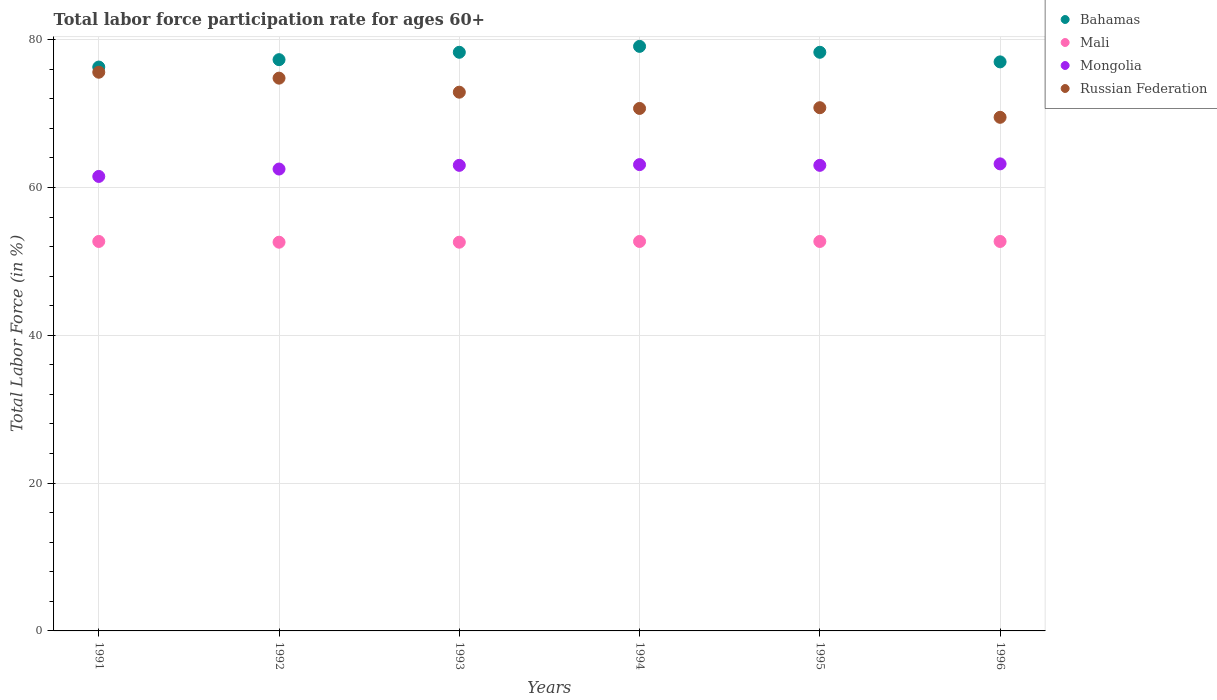How many different coloured dotlines are there?
Your answer should be compact. 4. What is the labor force participation rate in Mali in 1996?
Offer a terse response. 52.7. Across all years, what is the maximum labor force participation rate in Mongolia?
Your answer should be compact. 63.2. Across all years, what is the minimum labor force participation rate in Russian Federation?
Offer a terse response. 69.5. In which year was the labor force participation rate in Bahamas maximum?
Offer a terse response. 1994. What is the total labor force participation rate in Bahamas in the graph?
Provide a short and direct response. 466.3. What is the difference between the labor force participation rate in Mongolia in 1993 and that in 1994?
Keep it short and to the point. -0.1. What is the difference between the labor force participation rate in Russian Federation in 1994 and the labor force participation rate in Mali in 1992?
Offer a very short reply. 18.1. What is the average labor force participation rate in Russian Federation per year?
Your response must be concise. 72.38. In the year 1994, what is the difference between the labor force participation rate in Mongolia and labor force participation rate in Russian Federation?
Give a very brief answer. -7.6. Is the difference between the labor force participation rate in Mongolia in 1993 and 1996 greater than the difference between the labor force participation rate in Russian Federation in 1993 and 1996?
Ensure brevity in your answer.  No. What is the difference between the highest and the second highest labor force participation rate in Russian Federation?
Offer a terse response. 0.8. What is the difference between the highest and the lowest labor force participation rate in Mali?
Your answer should be compact. 0.1. In how many years, is the labor force participation rate in Mongolia greater than the average labor force participation rate in Mongolia taken over all years?
Offer a terse response. 4. Is the sum of the labor force participation rate in Bahamas in 1993 and 1996 greater than the maximum labor force participation rate in Russian Federation across all years?
Provide a succinct answer. Yes. Does the labor force participation rate in Mongolia monotonically increase over the years?
Make the answer very short. No. Is the labor force participation rate in Mongolia strictly greater than the labor force participation rate in Bahamas over the years?
Ensure brevity in your answer.  No. Is the labor force participation rate in Mali strictly less than the labor force participation rate in Russian Federation over the years?
Make the answer very short. Yes. How many years are there in the graph?
Your response must be concise. 6. What is the difference between two consecutive major ticks on the Y-axis?
Your answer should be very brief. 20. Are the values on the major ticks of Y-axis written in scientific E-notation?
Provide a short and direct response. No. Does the graph contain any zero values?
Keep it short and to the point. No. Does the graph contain grids?
Offer a terse response. Yes. Where does the legend appear in the graph?
Ensure brevity in your answer.  Top right. How are the legend labels stacked?
Offer a very short reply. Vertical. What is the title of the graph?
Your response must be concise. Total labor force participation rate for ages 60+. Does "Maldives" appear as one of the legend labels in the graph?
Offer a very short reply. No. What is the label or title of the X-axis?
Your response must be concise. Years. What is the Total Labor Force (in %) in Bahamas in 1991?
Provide a short and direct response. 76.3. What is the Total Labor Force (in %) in Mali in 1991?
Provide a short and direct response. 52.7. What is the Total Labor Force (in %) in Mongolia in 1991?
Provide a succinct answer. 61.5. What is the Total Labor Force (in %) in Russian Federation in 1991?
Keep it short and to the point. 75.6. What is the Total Labor Force (in %) in Bahamas in 1992?
Offer a very short reply. 77.3. What is the Total Labor Force (in %) of Mali in 1992?
Make the answer very short. 52.6. What is the Total Labor Force (in %) in Mongolia in 1992?
Ensure brevity in your answer.  62.5. What is the Total Labor Force (in %) of Russian Federation in 1992?
Your response must be concise. 74.8. What is the Total Labor Force (in %) of Bahamas in 1993?
Keep it short and to the point. 78.3. What is the Total Labor Force (in %) of Mali in 1993?
Ensure brevity in your answer.  52.6. What is the Total Labor Force (in %) of Russian Federation in 1993?
Provide a short and direct response. 72.9. What is the Total Labor Force (in %) of Bahamas in 1994?
Your answer should be compact. 79.1. What is the Total Labor Force (in %) of Mali in 1994?
Keep it short and to the point. 52.7. What is the Total Labor Force (in %) in Mongolia in 1994?
Your response must be concise. 63.1. What is the Total Labor Force (in %) of Russian Federation in 1994?
Your answer should be very brief. 70.7. What is the Total Labor Force (in %) in Bahamas in 1995?
Offer a very short reply. 78.3. What is the Total Labor Force (in %) in Mali in 1995?
Give a very brief answer. 52.7. What is the Total Labor Force (in %) in Mongolia in 1995?
Keep it short and to the point. 63. What is the Total Labor Force (in %) in Russian Federation in 1995?
Your response must be concise. 70.8. What is the Total Labor Force (in %) of Bahamas in 1996?
Your answer should be very brief. 77. What is the Total Labor Force (in %) in Mali in 1996?
Make the answer very short. 52.7. What is the Total Labor Force (in %) in Mongolia in 1996?
Make the answer very short. 63.2. What is the Total Labor Force (in %) in Russian Federation in 1996?
Your answer should be compact. 69.5. Across all years, what is the maximum Total Labor Force (in %) of Bahamas?
Provide a short and direct response. 79.1. Across all years, what is the maximum Total Labor Force (in %) of Mali?
Offer a terse response. 52.7. Across all years, what is the maximum Total Labor Force (in %) in Mongolia?
Give a very brief answer. 63.2. Across all years, what is the maximum Total Labor Force (in %) in Russian Federation?
Make the answer very short. 75.6. Across all years, what is the minimum Total Labor Force (in %) in Bahamas?
Make the answer very short. 76.3. Across all years, what is the minimum Total Labor Force (in %) in Mali?
Your answer should be compact. 52.6. Across all years, what is the minimum Total Labor Force (in %) in Mongolia?
Your answer should be very brief. 61.5. Across all years, what is the minimum Total Labor Force (in %) in Russian Federation?
Ensure brevity in your answer.  69.5. What is the total Total Labor Force (in %) of Bahamas in the graph?
Ensure brevity in your answer.  466.3. What is the total Total Labor Force (in %) of Mali in the graph?
Your answer should be very brief. 316. What is the total Total Labor Force (in %) of Mongolia in the graph?
Your answer should be very brief. 376.3. What is the total Total Labor Force (in %) in Russian Federation in the graph?
Provide a short and direct response. 434.3. What is the difference between the Total Labor Force (in %) of Mali in 1991 and that in 1992?
Your answer should be very brief. 0.1. What is the difference between the Total Labor Force (in %) of Russian Federation in 1991 and that in 1992?
Provide a succinct answer. 0.8. What is the difference between the Total Labor Force (in %) in Bahamas in 1991 and that in 1993?
Your response must be concise. -2. What is the difference between the Total Labor Force (in %) in Mali in 1991 and that in 1993?
Your answer should be compact. 0.1. What is the difference between the Total Labor Force (in %) of Mongolia in 1991 and that in 1993?
Provide a short and direct response. -1.5. What is the difference between the Total Labor Force (in %) of Bahamas in 1991 and that in 1995?
Provide a succinct answer. -2. What is the difference between the Total Labor Force (in %) of Mali in 1991 and that in 1995?
Ensure brevity in your answer.  0. What is the difference between the Total Labor Force (in %) of Mongolia in 1991 and that in 1995?
Your answer should be very brief. -1.5. What is the difference between the Total Labor Force (in %) in Bahamas in 1991 and that in 1996?
Provide a succinct answer. -0.7. What is the difference between the Total Labor Force (in %) in Mali in 1991 and that in 1996?
Ensure brevity in your answer.  0. What is the difference between the Total Labor Force (in %) in Russian Federation in 1991 and that in 1996?
Offer a terse response. 6.1. What is the difference between the Total Labor Force (in %) in Bahamas in 1992 and that in 1993?
Offer a very short reply. -1. What is the difference between the Total Labor Force (in %) in Mali in 1992 and that in 1993?
Offer a very short reply. 0. What is the difference between the Total Labor Force (in %) in Mongolia in 1992 and that in 1993?
Make the answer very short. -0.5. What is the difference between the Total Labor Force (in %) in Russian Federation in 1992 and that in 1993?
Keep it short and to the point. 1.9. What is the difference between the Total Labor Force (in %) in Bahamas in 1992 and that in 1994?
Your answer should be compact. -1.8. What is the difference between the Total Labor Force (in %) of Russian Federation in 1992 and that in 1994?
Provide a short and direct response. 4.1. What is the difference between the Total Labor Force (in %) in Russian Federation in 1992 and that in 1995?
Provide a short and direct response. 4. What is the difference between the Total Labor Force (in %) in Mali in 1992 and that in 1996?
Give a very brief answer. -0.1. What is the difference between the Total Labor Force (in %) in Mongolia in 1992 and that in 1996?
Your answer should be very brief. -0.7. What is the difference between the Total Labor Force (in %) of Bahamas in 1993 and that in 1994?
Give a very brief answer. -0.8. What is the difference between the Total Labor Force (in %) of Mali in 1993 and that in 1994?
Provide a succinct answer. -0.1. What is the difference between the Total Labor Force (in %) in Mongolia in 1993 and that in 1994?
Give a very brief answer. -0.1. What is the difference between the Total Labor Force (in %) in Russian Federation in 1993 and that in 1994?
Your answer should be compact. 2.2. What is the difference between the Total Labor Force (in %) of Bahamas in 1993 and that in 1995?
Offer a very short reply. 0. What is the difference between the Total Labor Force (in %) in Mali in 1993 and that in 1995?
Provide a short and direct response. -0.1. What is the difference between the Total Labor Force (in %) of Mongolia in 1993 and that in 1995?
Provide a succinct answer. 0. What is the difference between the Total Labor Force (in %) in Russian Federation in 1993 and that in 1995?
Give a very brief answer. 2.1. What is the difference between the Total Labor Force (in %) in Bahamas in 1994 and that in 1996?
Ensure brevity in your answer.  2.1. What is the difference between the Total Labor Force (in %) of Mali in 1994 and that in 1996?
Provide a succinct answer. 0. What is the difference between the Total Labor Force (in %) of Mongolia in 1994 and that in 1996?
Provide a succinct answer. -0.1. What is the difference between the Total Labor Force (in %) of Mali in 1995 and that in 1996?
Provide a succinct answer. 0. What is the difference between the Total Labor Force (in %) in Bahamas in 1991 and the Total Labor Force (in %) in Mali in 1992?
Your answer should be very brief. 23.7. What is the difference between the Total Labor Force (in %) of Bahamas in 1991 and the Total Labor Force (in %) of Mongolia in 1992?
Offer a terse response. 13.8. What is the difference between the Total Labor Force (in %) in Mali in 1991 and the Total Labor Force (in %) in Russian Federation in 1992?
Keep it short and to the point. -22.1. What is the difference between the Total Labor Force (in %) in Bahamas in 1991 and the Total Labor Force (in %) in Mali in 1993?
Provide a short and direct response. 23.7. What is the difference between the Total Labor Force (in %) in Bahamas in 1991 and the Total Labor Force (in %) in Mongolia in 1993?
Provide a succinct answer. 13.3. What is the difference between the Total Labor Force (in %) in Mali in 1991 and the Total Labor Force (in %) in Mongolia in 1993?
Your response must be concise. -10.3. What is the difference between the Total Labor Force (in %) in Mali in 1991 and the Total Labor Force (in %) in Russian Federation in 1993?
Keep it short and to the point. -20.2. What is the difference between the Total Labor Force (in %) in Bahamas in 1991 and the Total Labor Force (in %) in Mali in 1994?
Keep it short and to the point. 23.6. What is the difference between the Total Labor Force (in %) in Mali in 1991 and the Total Labor Force (in %) in Mongolia in 1994?
Provide a short and direct response. -10.4. What is the difference between the Total Labor Force (in %) in Mongolia in 1991 and the Total Labor Force (in %) in Russian Federation in 1994?
Keep it short and to the point. -9.2. What is the difference between the Total Labor Force (in %) in Bahamas in 1991 and the Total Labor Force (in %) in Mali in 1995?
Your response must be concise. 23.6. What is the difference between the Total Labor Force (in %) in Bahamas in 1991 and the Total Labor Force (in %) in Mongolia in 1995?
Ensure brevity in your answer.  13.3. What is the difference between the Total Labor Force (in %) in Mali in 1991 and the Total Labor Force (in %) in Mongolia in 1995?
Ensure brevity in your answer.  -10.3. What is the difference between the Total Labor Force (in %) in Mali in 1991 and the Total Labor Force (in %) in Russian Federation in 1995?
Make the answer very short. -18.1. What is the difference between the Total Labor Force (in %) in Mongolia in 1991 and the Total Labor Force (in %) in Russian Federation in 1995?
Give a very brief answer. -9.3. What is the difference between the Total Labor Force (in %) in Bahamas in 1991 and the Total Labor Force (in %) in Mali in 1996?
Ensure brevity in your answer.  23.6. What is the difference between the Total Labor Force (in %) of Bahamas in 1991 and the Total Labor Force (in %) of Mongolia in 1996?
Provide a short and direct response. 13.1. What is the difference between the Total Labor Force (in %) of Mali in 1991 and the Total Labor Force (in %) of Mongolia in 1996?
Your response must be concise. -10.5. What is the difference between the Total Labor Force (in %) in Mali in 1991 and the Total Labor Force (in %) in Russian Federation in 1996?
Your answer should be compact. -16.8. What is the difference between the Total Labor Force (in %) of Mongolia in 1991 and the Total Labor Force (in %) of Russian Federation in 1996?
Keep it short and to the point. -8. What is the difference between the Total Labor Force (in %) in Bahamas in 1992 and the Total Labor Force (in %) in Mali in 1993?
Offer a very short reply. 24.7. What is the difference between the Total Labor Force (in %) of Bahamas in 1992 and the Total Labor Force (in %) of Mongolia in 1993?
Ensure brevity in your answer.  14.3. What is the difference between the Total Labor Force (in %) of Bahamas in 1992 and the Total Labor Force (in %) of Russian Federation in 1993?
Your answer should be very brief. 4.4. What is the difference between the Total Labor Force (in %) of Mali in 1992 and the Total Labor Force (in %) of Mongolia in 1993?
Give a very brief answer. -10.4. What is the difference between the Total Labor Force (in %) in Mali in 1992 and the Total Labor Force (in %) in Russian Federation in 1993?
Offer a very short reply. -20.3. What is the difference between the Total Labor Force (in %) of Mongolia in 1992 and the Total Labor Force (in %) of Russian Federation in 1993?
Make the answer very short. -10.4. What is the difference between the Total Labor Force (in %) of Bahamas in 1992 and the Total Labor Force (in %) of Mali in 1994?
Give a very brief answer. 24.6. What is the difference between the Total Labor Force (in %) in Mali in 1992 and the Total Labor Force (in %) in Russian Federation in 1994?
Your answer should be compact. -18.1. What is the difference between the Total Labor Force (in %) of Bahamas in 1992 and the Total Labor Force (in %) of Mali in 1995?
Your answer should be very brief. 24.6. What is the difference between the Total Labor Force (in %) of Bahamas in 1992 and the Total Labor Force (in %) of Russian Federation in 1995?
Keep it short and to the point. 6.5. What is the difference between the Total Labor Force (in %) of Mali in 1992 and the Total Labor Force (in %) of Mongolia in 1995?
Keep it short and to the point. -10.4. What is the difference between the Total Labor Force (in %) of Mali in 1992 and the Total Labor Force (in %) of Russian Federation in 1995?
Give a very brief answer. -18.2. What is the difference between the Total Labor Force (in %) of Mongolia in 1992 and the Total Labor Force (in %) of Russian Federation in 1995?
Offer a very short reply. -8.3. What is the difference between the Total Labor Force (in %) in Bahamas in 1992 and the Total Labor Force (in %) in Mali in 1996?
Keep it short and to the point. 24.6. What is the difference between the Total Labor Force (in %) of Bahamas in 1992 and the Total Labor Force (in %) of Mongolia in 1996?
Keep it short and to the point. 14.1. What is the difference between the Total Labor Force (in %) in Mali in 1992 and the Total Labor Force (in %) in Mongolia in 1996?
Offer a terse response. -10.6. What is the difference between the Total Labor Force (in %) of Mali in 1992 and the Total Labor Force (in %) of Russian Federation in 1996?
Your answer should be very brief. -16.9. What is the difference between the Total Labor Force (in %) of Mongolia in 1992 and the Total Labor Force (in %) of Russian Federation in 1996?
Give a very brief answer. -7. What is the difference between the Total Labor Force (in %) of Bahamas in 1993 and the Total Labor Force (in %) of Mali in 1994?
Offer a very short reply. 25.6. What is the difference between the Total Labor Force (in %) of Bahamas in 1993 and the Total Labor Force (in %) of Russian Federation in 1994?
Your response must be concise. 7.6. What is the difference between the Total Labor Force (in %) of Mali in 1993 and the Total Labor Force (in %) of Mongolia in 1994?
Your answer should be compact. -10.5. What is the difference between the Total Labor Force (in %) in Mali in 1993 and the Total Labor Force (in %) in Russian Federation in 1994?
Keep it short and to the point. -18.1. What is the difference between the Total Labor Force (in %) in Bahamas in 1993 and the Total Labor Force (in %) in Mali in 1995?
Offer a very short reply. 25.6. What is the difference between the Total Labor Force (in %) in Bahamas in 1993 and the Total Labor Force (in %) in Russian Federation in 1995?
Your response must be concise. 7.5. What is the difference between the Total Labor Force (in %) in Mali in 1993 and the Total Labor Force (in %) in Mongolia in 1995?
Offer a terse response. -10.4. What is the difference between the Total Labor Force (in %) of Mali in 1993 and the Total Labor Force (in %) of Russian Federation in 1995?
Your response must be concise. -18.2. What is the difference between the Total Labor Force (in %) of Mongolia in 1993 and the Total Labor Force (in %) of Russian Federation in 1995?
Give a very brief answer. -7.8. What is the difference between the Total Labor Force (in %) in Bahamas in 1993 and the Total Labor Force (in %) in Mali in 1996?
Provide a short and direct response. 25.6. What is the difference between the Total Labor Force (in %) in Bahamas in 1993 and the Total Labor Force (in %) in Mongolia in 1996?
Give a very brief answer. 15.1. What is the difference between the Total Labor Force (in %) in Mali in 1993 and the Total Labor Force (in %) in Russian Federation in 1996?
Give a very brief answer. -16.9. What is the difference between the Total Labor Force (in %) in Bahamas in 1994 and the Total Labor Force (in %) in Mali in 1995?
Make the answer very short. 26.4. What is the difference between the Total Labor Force (in %) in Bahamas in 1994 and the Total Labor Force (in %) in Russian Federation in 1995?
Give a very brief answer. 8.3. What is the difference between the Total Labor Force (in %) in Mali in 1994 and the Total Labor Force (in %) in Mongolia in 1995?
Keep it short and to the point. -10.3. What is the difference between the Total Labor Force (in %) in Mali in 1994 and the Total Labor Force (in %) in Russian Federation in 1995?
Ensure brevity in your answer.  -18.1. What is the difference between the Total Labor Force (in %) in Bahamas in 1994 and the Total Labor Force (in %) in Mali in 1996?
Ensure brevity in your answer.  26.4. What is the difference between the Total Labor Force (in %) in Bahamas in 1994 and the Total Labor Force (in %) in Mongolia in 1996?
Offer a very short reply. 15.9. What is the difference between the Total Labor Force (in %) in Mali in 1994 and the Total Labor Force (in %) in Russian Federation in 1996?
Your answer should be compact. -16.8. What is the difference between the Total Labor Force (in %) of Bahamas in 1995 and the Total Labor Force (in %) of Mali in 1996?
Your answer should be very brief. 25.6. What is the difference between the Total Labor Force (in %) in Bahamas in 1995 and the Total Labor Force (in %) in Russian Federation in 1996?
Your answer should be very brief. 8.8. What is the difference between the Total Labor Force (in %) in Mali in 1995 and the Total Labor Force (in %) in Mongolia in 1996?
Your response must be concise. -10.5. What is the difference between the Total Labor Force (in %) of Mali in 1995 and the Total Labor Force (in %) of Russian Federation in 1996?
Make the answer very short. -16.8. What is the difference between the Total Labor Force (in %) in Mongolia in 1995 and the Total Labor Force (in %) in Russian Federation in 1996?
Ensure brevity in your answer.  -6.5. What is the average Total Labor Force (in %) of Bahamas per year?
Your answer should be very brief. 77.72. What is the average Total Labor Force (in %) in Mali per year?
Keep it short and to the point. 52.67. What is the average Total Labor Force (in %) of Mongolia per year?
Your answer should be compact. 62.72. What is the average Total Labor Force (in %) of Russian Federation per year?
Your response must be concise. 72.38. In the year 1991, what is the difference between the Total Labor Force (in %) in Bahamas and Total Labor Force (in %) in Mali?
Offer a very short reply. 23.6. In the year 1991, what is the difference between the Total Labor Force (in %) in Bahamas and Total Labor Force (in %) in Russian Federation?
Provide a short and direct response. 0.7. In the year 1991, what is the difference between the Total Labor Force (in %) of Mali and Total Labor Force (in %) of Russian Federation?
Make the answer very short. -22.9. In the year 1991, what is the difference between the Total Labor Force (in %) in Mongolia and Total Labor Force (in %) in Russian Federation?
Provide a succinct answer. -14.1. In the year 1992, what is the difference between the Total Labor Force (in %) in Bahamas and Total Labor Force (in %) in Mali?
Your response must be concise. 24.7. In the year 1992, what is the difference between the Total Labor Force (in %) of Bahamas and Total Labor Force (in %) of Russian Federation?
Your response must be concise. 2.5. In the year 1992, what is the difference between the Total Labor Force (in %) of Mali and Total Labor Force (in %) of Russian Federation?
Your answer should be very brief. -22.2. In the year 1992, what is the difference between the Total Labor Force (in %) of Mongolia and Total Labor Force (in %) of Russian Federation?
Offer a very short reply. -12.3. In the year 1993, what is the difference between the Total Labor Force (in %) of Bahamas and Total Labor Force (in %) of Mali?
Your answer should be very brief. 25.7. In the year 1993, what is the difference between the Total Labor Force (in %) of Bahamas and Total Labor Force (in %) of Russian Federation?
Offer a very short reply. 5.4. In the year 1993, what is the difference between the Total Labor Force (in %) of Mali and Total Labor Force (in %) of Russian Federation?
Offer a very short reply. -20.3. In the year 1994, what is the difference between the Total Labor Force (in %) in Bahamas and Total Labor Force (in %) in Mali?
Your answer should be very brief. 26.4. In the year 1994, what is the difference between the Total Labor Force (in %) in Bahamas and Total Labor Force (in %) in Mongolia?
Give a very brief answer. 16. In the year 1994, what is the difference between the Total Labor Force (in %) of Bahamas and Total Labor Force (in %) of Russian Federation?
Provide a succinct answer. 8.4. In the year 1994, what is the difference between the Total Labor Force (in %) in Mali and Total Labor Force (in %) in Mongolia?
Make the answer very short. -10.4. In the year 1995, what is the difference between the Total Labor Force (in %) in Bahamas and Total Labor Force (in %) in Mali?
Keep it short and to the point. 25.6. In the year 1995, what is the difference between the Total Labor Force (in %) of Bahamas and Total Labor Force (in %) of Mongolia?
Your answer should be very brief. 15.3. In the year 1995, what is the difference between the Total Labor Force (in %) in Mali and Total Labor Force (in %) in Mongolia?
Offer a very short reply. -10.3. In the year 1995, what is the difference between the Total Labor Force (in %) of Mali and Total Labor Force (in %) of Russian Federation?
Your answer should be compact. -18.1. In the year 1996, what is the difference between the Total Labor Force (in %) of Bahamas and Total Labor Force (in %) of Mali?
Your response must be concise. 24.3. In the year 1996, what is the difference between the Total Labor Force (in %) in Mali and Total Labor Force (in %) in Russian Federation?
Your response must be concise. -16.8. What is the ratio of the Total Labor Force (in %) in Bahamas in 1991 to that in 1992?
Your answer should be compact. 0.99. What is the ratio of the Total Labor Force (in %) in Mongolia in 1991 to that in 1992?
Keep it short and to the point. 0.98. What is the ratio of the Total Labor Force (in %) in Russian Federation in 1991 to that in 1992?
Your answer should be very brief. 1.01. What is the ratio of the Total Labor Force (in %) of Bahamas in 1991 to that in 1993?
Keep it short and to the point. 0.97. What is the ratio of the Total Labor Force (in %) of Mali in 1991 to that in 1993?
Make the answer very short. 1. What is the ratio of the Total Labor Force (in %) of Mongolia in 1991 to that in 1993?
Provide a short and direct response. 0.98. What is the ratio of the Total Labor Force (in %) of Bahamas in 1991 to that in 1994?
Make the answer very short. 0.96. What is the ratio of the Total Labor Force (in %) of Mongolia in 1991 to that in 1994?
Provide a short and direct response. 0.97. What is the ratio of the Total Labor Force (in %) of Russian Federation in 1991 to that in 1994?
Give a very brief answer. 1.07. What is the ratio of the Total Labor Force (in %) of Bahamas in 1991 to that in 1995?
Give a very brief answer. 0.97. What is the ratio of the Total Labor Force (in %) of Mongolia in 1991 to that in 1995?
Provide a succinct answer. 0.98. What is the ratio of the Total Labor Force (in %) of Russian Federation in 1991 to that in 1995?
Your response must be concise. 1.07. What is the ratio of the Total Labor Force (in %) of Bahamas in 1991 to that in 1996?
Ensure brevity in your answer.  0.99. What is the ratio of the Total Labor Force (in %) of Mali in 1991 to that in 1996?
Give a very brief answer. 1. What is the ratio of the Total Labor Force (in %) in Mongolia in 1991 to that in 1996?
Give a very brief answer. 0.97. What is the ratio of the Total Labor Force (in %) in Russian Federation in 1991 to that in 1996?
Your response must be concise. 1.09. What is the ratio of the Total Labor Force (in %) of Bahamas in 1992 to that in 1993?
Offer a very short reply. 0.99. What is the ratio of the Total Labor Force (in %) of Russian Federation in 1992 to that in 1993?
Keep it short and to the point. 1.03. What is the ratio of the Total Labor Force (in %) in Bahamas in 1992 to that in 1994?
Provide a succinct answer. 0.98. What is the ratio of the Total Labor Force (in %) of Russian Federation in 1992 to that in 1994?
Your answer should be very brief. 1.06. What is the ratio of the Total Labor Force (in %) in Bahamas in 1992 to that in 1995?
Give a very brief answer. 0.99. What is the ratio of the Total Labor Force (in %) of Russian Federation in 1992 to that in 1995?
Make the answer very short. 1.06. What is the ratio of the Total Labor Force (in %) of Bahamas in 1992 to that in 1996?
Provide a succinct answer. 1. What is the ratio of the Total Labor Force (in %) in Mali in 1992 to that in 1996?
Offer a terse response. 1. What is the ratio of the Total Labor Force (in %) in Mongolia in 1992 to that in 1996?
Make the answer very short. 0.99. What is the ratio of the Total Labor Force (in %) of Russian Federation in 1992 to that in 1996?
Your answer should be compact. 1.08. What is the ratio of the Total Labor Force (in %) in Bahamas in 1993 to that in 1994?
Make the answer very short. 0.99. What is the ratio of the Total Labor Force (in %) in Mongolia in 1993 to that in 1994?
Provide a succinct answer. 1. What is the ratio of the Total Labor Force (in %) of Russian Federation in 1993 to that in 1994?
Your response must be concise. 1.03. What is the ratio of the Total Labor Force (in %) of Bahamas in 1993 to that in 1995?
Your answer should be compact. 1. What is the ratio of the Total Labor Force (in %) of Mali in 1993 to that in 1995?
Keep it short and to the point. 1. What is the ratio of the Total Labor Force (in %) in Mongolia in 1993 to that in 1995?
Make the answer very short. 1. What is the ratio of the Total Labor Force (in %) in Russian Federation in 1993 to that in 1995?
Give a very brief answer. 1.03. What is the ratio of the Total Labor Force (in %) of Bahamas in 1993 to that in 1996?
Your answer should be very brief. 1.02. What is the ratio of the Total Labor Force (in %) of Russian Federation in 1993 to that in 1996?
Ensure brevity in your answer.  1.05. What is the ratio of the Total Labor Force (in %) of Bahamas in 1994 to that in 1995?
Make the answer very short. 1.01. What is the ratio of the Total Labor Force (in %) of Bahamas in 1994 to that in 1996?
Give a very brief answer. 1.03. What is the ratio of the Total Labor Force (in %) in Mali in 1994 to that in 1996?
Give a very brief answer. 1. What is the ratio of the Total Labor Force (in %) of Russian Federation in 1994 to that in 1996?
Provide a succinct answer. 1.02. What is the ratio of the Total Labor Force (in %) in Bahamas in 1995 to that in 1996?
Provide a short and direct response. 1.02. What is the ratio of the Total Labor Force (in %) in Mali in 1995 to that in 1996?
Provide a succinct answer. 1. What is the ratio of the Total Labor Force (in %) of Mongolia in 1995 to that in 1996?
Keep it short and to the point. 1. What is the ratio of the Total Labor Force (in %) in Russian Federation in 1995 to that in 1996?
Make the answer very short. 1.02. What is the difference between the highest and the second highest Total Labor Force (in %) in Bahamas?
Give a very brief answer. 0.8. What is the difference between the highest and the second highest Total Labor Force (in %) in Mongolia?
Your answer should be very brief. 0.1. What is the difference between the highest and the second highest Total Labor Force (in %) of Russian Federation?
Offer a terse response. 0.8. What is the difference between the highest and the lowest Total Labor Force (in %) in Russian Federation?
Make the answer very short. 6.1. 